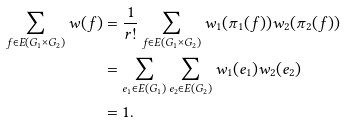Convert formula to latex. <formula><loc_0><loc_0><loc_500><loc_500>\sum _ { f \in E ( G _ { 1 } \times G _ { 2 } ) } w ( f ) & = \frac { 1 } { r ! } \sum _ { f \in E ( G _ { 1 } \times G _ { 2 } ) } w _ { 1 } ( \pi _ { 1 } ( f ) ) w _ { 2 } ( \pi _ { 2 } ( f ) ) \\ & = \sum _ { e _ { 1 } \in E ( G _ { 1 } ) } \sum _ { e _ { 2 } \in E ( G _ { 2 } ) } w _ { 1 } ( e _ { 1 } ) w _ { 2 } ( e _ { 2 } ) \\ & = 1 .</formula> 